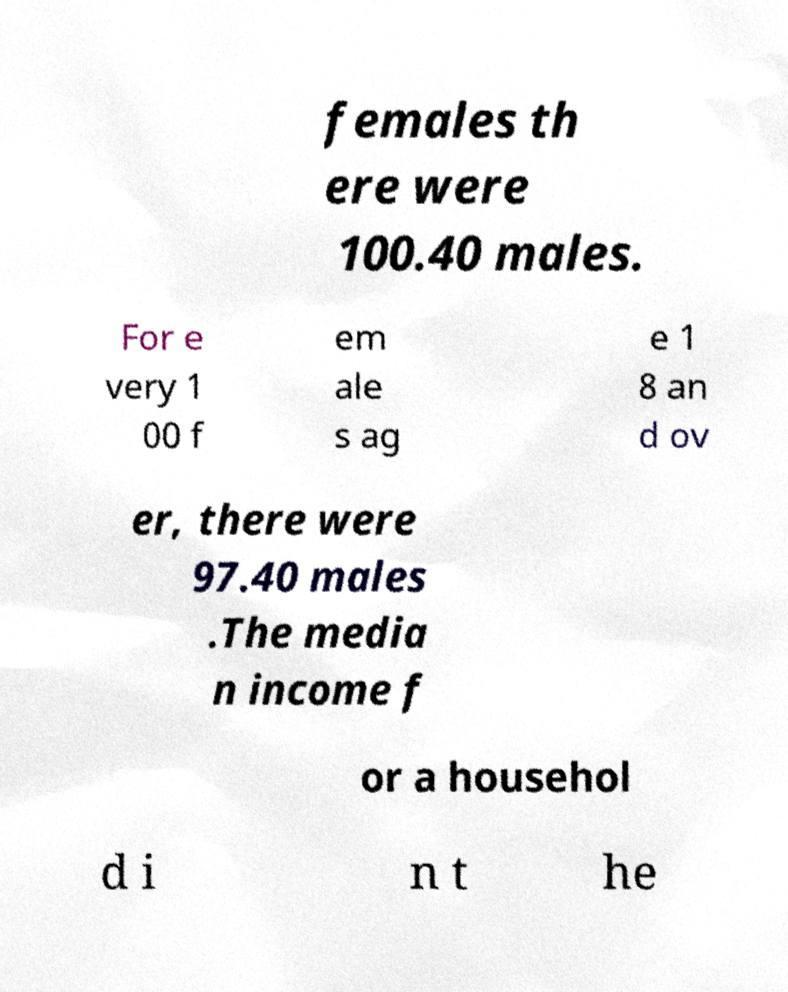Please read and relay the text visible in this image. What does it say? females th ere were 100.40 males. For e very 1 00 f em ale s ag e 1 8 an d ov er, there were 97.40 males .The media n income f or a househol d i n t he 